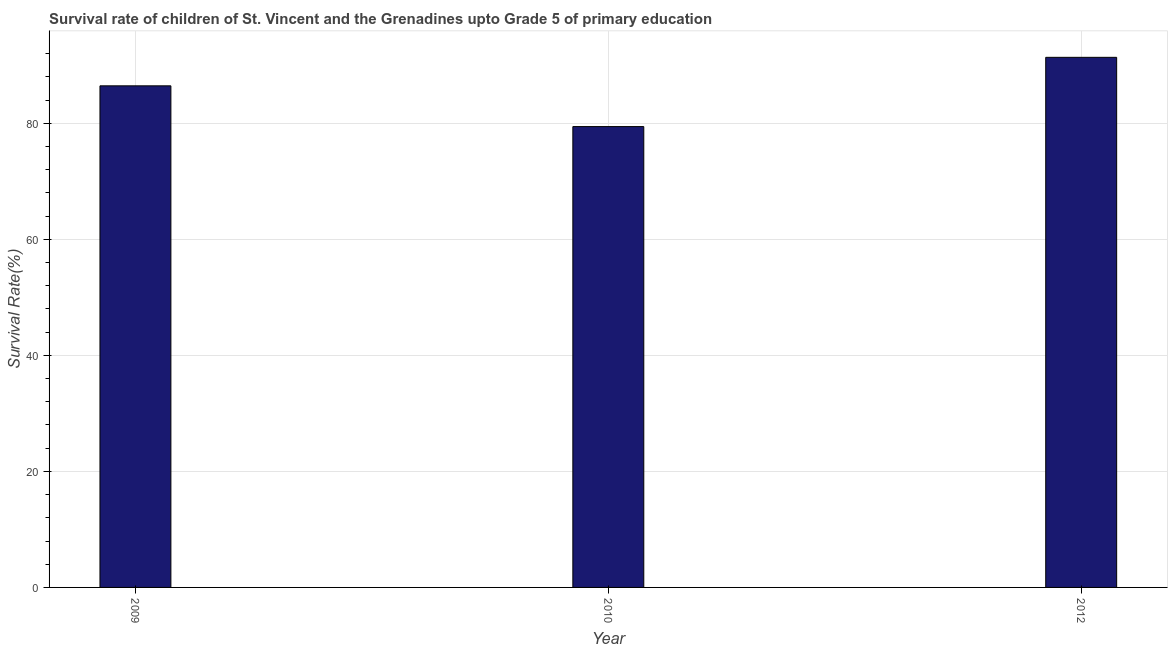Does the graph contain any zero values?
Offer a very short reply. No. What is the title of the graph?
Your response must be concise. Survival rate of children of St. Vincent and the Grenadines upto Grade 5 of primary education. What is the label or title of the X-axis?
Keep it short and to the point. Year. What is the label or title of the Y-axis?
Offer a terse response. Survival Rate(%). What is the survival rate in 2010?
Offer a terse response. 79.43. Across all years, what is the maximum survival rate?
Make the answer very short. 91.37. Across all years, what is the minimum survival rate?
Your answer should be compact. 79.43. In which year was the survival rate minimum?
Your response must be concise. 2010. What is the sum of the survival rate?
Your answer should be very brief. 257.25. What is the difference between the survival rate in 2010 and 2012?
Your answer should be compact. -11.94. What is the average survival rate per year?
Your answer should be compact. 85.75. What is the median survival rate?
Your answer should be very brief. 86.46. In how many years, is the survival rate greater than 72 %?
Provide a short and direct response. 3. What is the ratio of the survival rate in 2009 to that in 2012?
Ensure brevity in your answer.  0.95. What is the difference between the highest and the second highest survival rate?
Ensure brevity in your answer.  4.91. What is the difference between the highest and the lowest survival rate?
Give a very brief answer. 11.94. Are all the bars in the graph horizontal?
Offer a very short reply. No. How many years are there in the graph?
Give a very brief answer. 3. What is the difference between two consecutive major ticks on the Y-axis?
Your response must be concise. 20. Are the values on the major ticks of Y-axis written in scientific E-notation?
Provide a succinct answer. No. What is the Survival Rate(%) of 2009?
Your response must be concise. 86.46. What is the Survival Rate(%) of 2010?
Make the answer very short. 79.43. What is the Survival Rate(%) in 2012?
Offer a terse response. 91.37. What is the difference between the Survival Rate(%) in 2009 and 2010?
Your answer should be compact. 7.02. What is the difference between the Survival Rate(%) in 2009 and 2012?
Make the answer very short. -4.91. What is the difference between the Survival Rate(%) in 2010 and 2012?
Provide a succinct answer. -11.94. What is the ratio of the Survival Rate(%) in 2009 to that in 2010?
Your answer should be very brief. 1.09. What is the ratio of the Survival Rate(%) in 2009 to that in 2012?
Offer a terse response. 0.95. What is the ratio of the Survival Rate(%) in 2010 to that in 2012?
Offer a terse response. 0.87. 